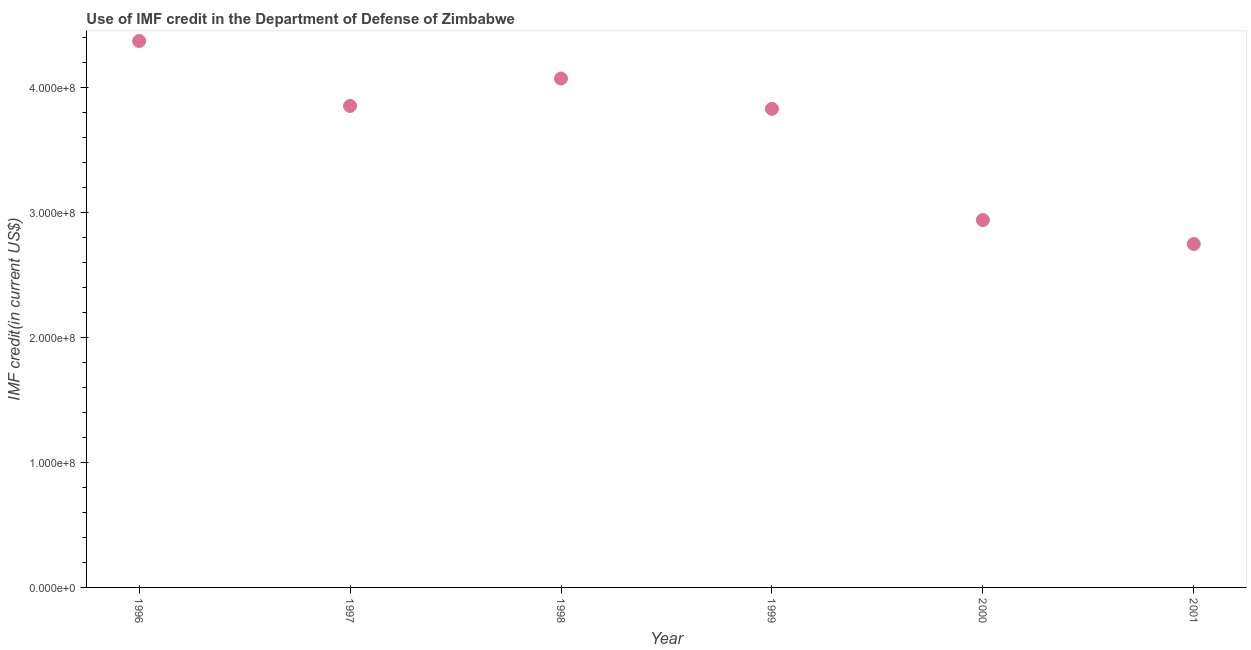What is the use of imf credit in dod in 2001?
Provide a succinct answer. 2.75e+08. Across all years, what is the maximum use of imf credit in dod?
Provide a succinct answer. 4.37e+08. Across all years, what is the minimum use of imf credit in dod?
Offer a terse response. 2.75e+08. In which year was the use of imf credit in dod maximum?
Keep it short and to the point. 1996. In which year was the use of imf credit in dod minimum?
Make the answer very short. 2001. What is the sum of the use of imf credit in dod?
Give a very brief answer. 2.18e+09. What is the difference between the use of imf credit in dod in 1996 and 1999?
Keep it short and to the point. 5.43e+07. What is the average use of imf credit in dod per year?
Your answer should be compact. 3.64e+08. What is the median use of imf credit in dod?
Your answer should be very brief. 3.84e+08. Do a majority of the years between 1999 and 2001 (inclusive) have use of imf credit in dod greater than 120000000 US$?
Keep it short and to the point. Yes. What is the ratio of the use of imf credit in dod in 2000 to that in 2001?
Provide a short and direct response. 1.07. Is the difference between the use of imf credit in dod in 1998 and 1999 greater than the difference between any two years?
Make the answer very short. No. What is the difference between the highest and the second highest use of imf credit in dod?
Offer a terse response. 3.01e+07. What is the difference between the highest and the lowest use of imf credit in dod?
Provide a succinct answer. 1.62e+08. Does the use of imf credit in dod monotonically increase over the years?
Provide a short and direct response. No. How many dotlines are there?
Offer a terse response. 1. How many years are there in the graph?
Your answer should be very brief. 6. What is the title of the graph?
Your response must be concise. Use of IMF credit in the Department of Defense of Zimbabwe. What is the label or title of the Y-axis?
Offer a terse response. IMF credit(in current US$). What is the IMF credit(in current US$) in 1996?
Ensure brevity in your answer.  4.37e+08. What is the IMF credit(in current US$) in 1997?
Provide a short and direct response. 3.85e+08. What is the IMF credit(in current US$) in 1998?
Your answer should be very brief. 4.07e+08. What is the IMF credit(in current US$) in 1999?
Offer a terse response. 3.83e+08. What is the IMF credit(in current US$) in 2000?
Make the answer very short. 2.94e+08. What is the IMF credit(in current US$) in 2001?
Give a very brief answer. 2.75e+08. What is the difference between the IMF credit(in current US$) in 1996 and 1997?
Offer a terse response. 5.20e+07. What is the difference between the IMF credit(in current US$) in 1996 and 1998?
Ensure brevity in your answer.  3.01e+07. What is the difference between the IMF credit(in current US$) in 1996 and 1999?
Provide a succinct answer. 5.43e+07. What is the difference between the IMF credit(in current US$) in 1996 and 2000?
Give a very brief answer. 1.43e+08. What is the difference between the IMF credit(in current US$) in 1996 and 2001?
Your answer should be very brief. 1.62e+08. What is the difference between the IMF credit(in current US$) in 1997 and 1998?
Provide a succinct answer. -2.19e+07. What is the difference between the IMF credit(in current US$) in 1997 and 1999?
Keep it short and to the point. 2.32e+06. What is the difference between the IMF credit(in current US$) in 1997 and 2000?
Give a very brief answer. 9.13e+07. What is the difference between the IMF credit(in current US$) in 1997 and 2001?
Offer a very short reply. 1.10e+08. What is the difference between the IMF credit(in current US$) in 1998 and 1999?
Your response must be concise. 2.42e+07. What is the difference between the IMF credit(in current US$) in 1998 and 2000?
Offer a terse response. 1.13e+08. What is the difference between the IMF credit(in current US$) in 1998 and 2001?
Your answer should be very brief. 1.32e+08. What is the difference between the IMF credit(in current US$) in 1999 and 2000?
Your answer should be very brief. 8.90e+07. What is the difference between the IMF credit(in current US$) in 1999 and 2001?
Make the answer very short. 1.08e+08. What is the difference between the IMF credit(in current US$) in 2000 and 2001?
Provide a succinct answer. 1.92e+07. What is the ratio of the IMF credit(in current US$) in 1996 to that in 1997?
Offer a very short reply. 1.14. What is the ratio of the IMF credit(in current US$) in 1996 to that in 1998?
Your response must be concise. 1.07. What is the ratio of the IMF credit(in current US$) in 1996 to that in 1999?
Your answer should be compact. 1.14. What is the ratio of the IMF credit(in current US$) in 1996 to that in 2000?
Offer a very short reply. 1.49. What is the ratio of the IMF credit(in current US$) in 1996 to that in 2001?
Keep it short and to the point. 1.59. What is the ratio of the IMF credit(in current US$) in 1997 to that in 1998?
Offer a very short reply. 0.95. What is the ratio of the IMF credit(in current US$) in 1997 to that in 2000?
Make the answer very short. 1.31. What is the ratio of the IMF credit(in current US$) in 1997 to that in 2001?
Offer a terse response. 1.4. What is the ratio of the IMF credit(in current US$) in 1998 to that in 1999?
Give a very brief answer. 1.06. What is the ratio of the IMF credit(in current US$) in 1998 to that in 2000?
Keep it short and to the point. 1.39. What is the ratio of the IMF credit(in current US$) in 1998 to that in 2001?
Provide a short and direct response. 1.48. What is the ratio of the IMF credit(in current US$) in 1999 to that in 2000?
Provide a succinct answer. 1.3. What is the ratio of the IMF credit(in current US$) in 1999 to that in 2001?
Give a very brief answer. 1.39. What is the ratio of the IMF credit(in current US$) in 2000 to that in 2001?
Keep it short and to the point. 1.07. 